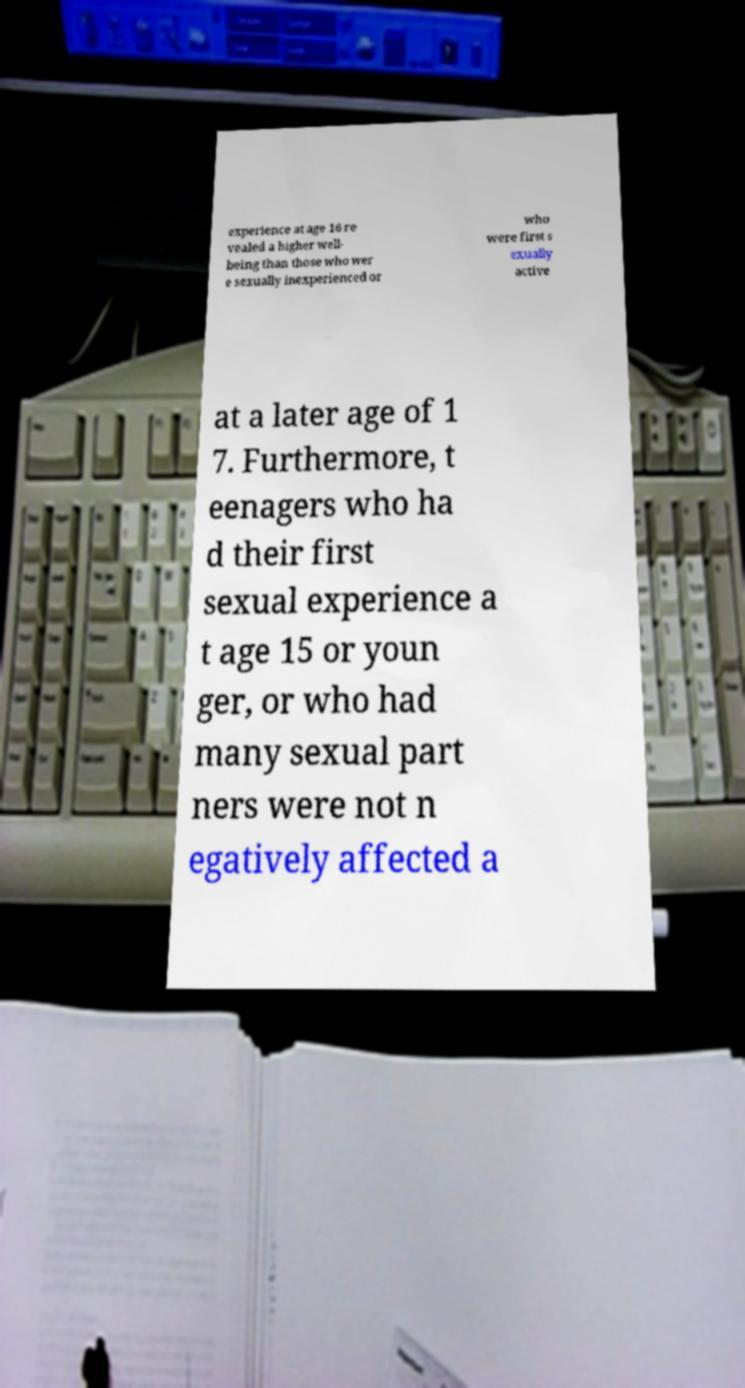Please read and relay the text visible in this image. What does it say? experience at age 16 re vealed a higher well- being than those who wer e sexually inexperienced or who were first s exually active at a later age of 1 7. Furthermore, t eenagers who ha d their first sexual experience a t age 15 or youn ger, or who had many sexual part ners were not n egatively affected a 